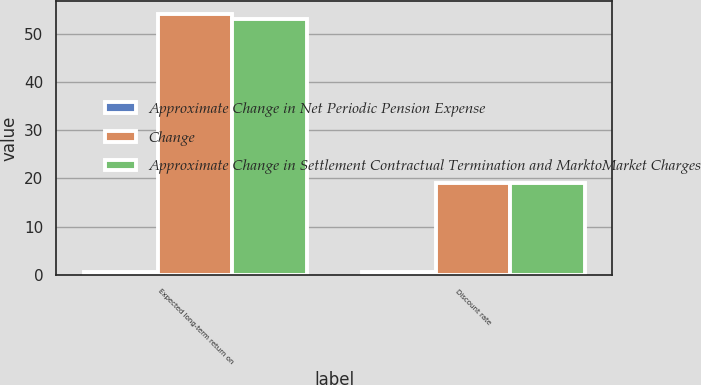Convert chart to OTSL. <chart><loc_0><loc_0><loc_500><loc_500><stacked_bar_chart><ecel><fcel>Expected long-term return on<fcel>Discount rate<nl><fcel>Approximate Change in Net Periodic Pension Expense<fcel>0.5<fcel>0.5<nl><fcel>Change<fcel>54<fcel>19<nl><fcel>Approximate Change in Settlement Contractual Termination and MarktoMarket Charges<fcel>53<fcel>19<nl></chart> 